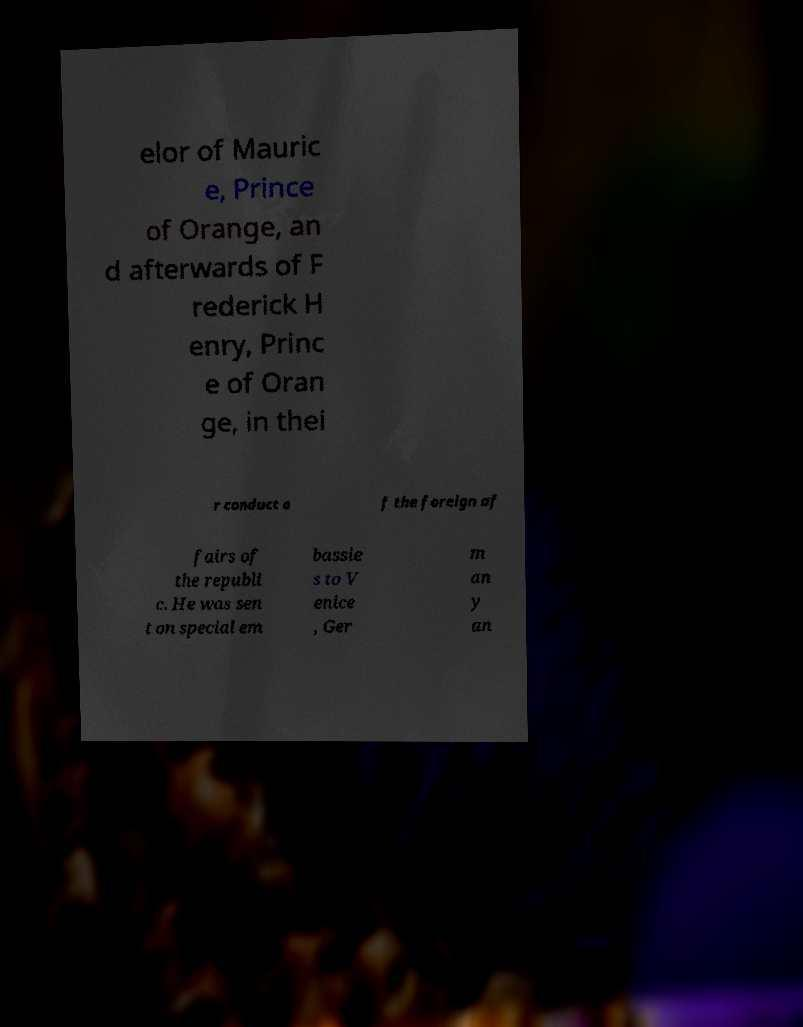For documentation purposes, I need the text within this image transcribed. Could you provide that? elor of Mauric e, Prince of Orange, an d afterwards of F rederick H enry, Princ e of Oran ge, in thei r conduct o f the foreign af fairs of the republi c. He was sen t on special em bassie s to V enice , Ger m an y an 